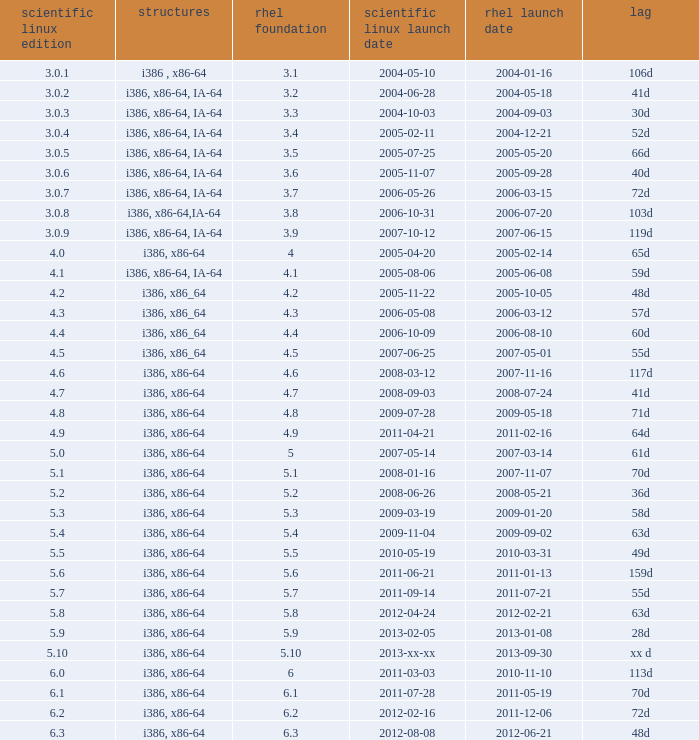When is the rhel release date when scientific linux release is 3.0.4 2004-12-21. 